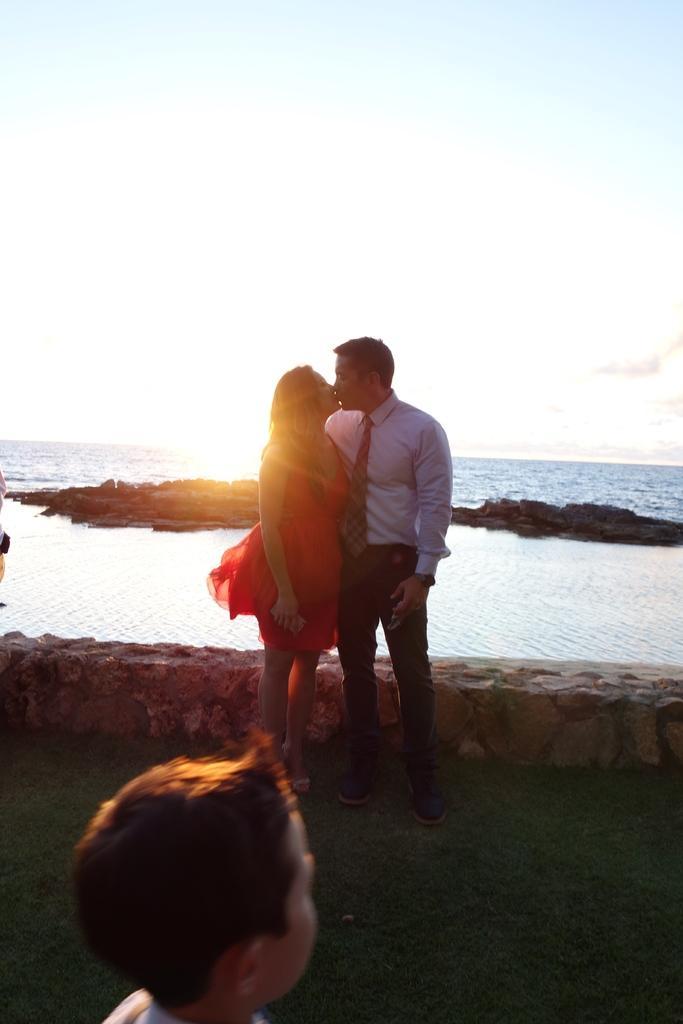How would you summarize this image in a sentence or two? In this picture we can see there are two people standing and in front of the people there is a boy. Behind the people there is water and a sky. 